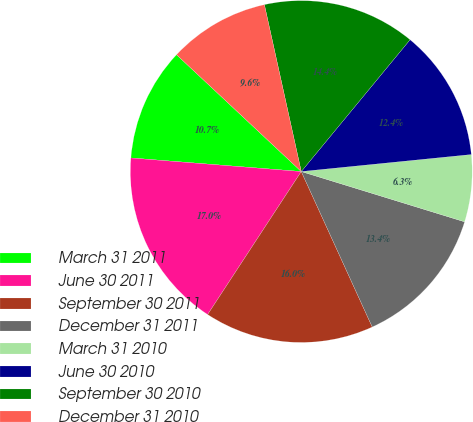Convert chart. <chart><loc_0><loc_0><loc_500><loc_500><pie_chart><fcel>March 31 2011<fcel>June 30 2011<fcel>September 30 2011<fcel>December 31 2011<fcel>March 31 2010<fcel>June 30 2010<fcel>September 30 2010<fcel>December 31 2010<nl><fcel>10.71%<fcel>17.04%<fcel>16.04%<fcel>13.43%<fcel>6.34%<fcel>12.43%<fcel>14.44%<fcel>9.56%<nl></chart> 